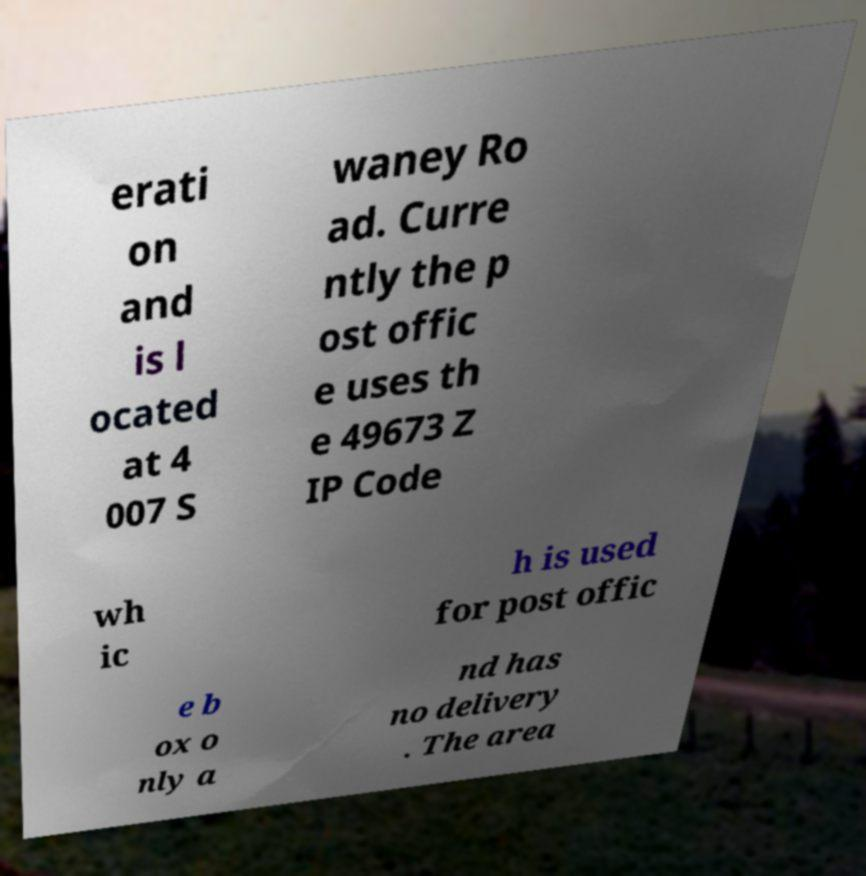What messages or text are displayed in this image? I need them in a readable, typed format. erati on and is l ocated at 4 007 S waney Ro ad. Curre ntly the p ost offic e uses th e 49673 Z IP Code wh ic h is used for post offic e b ox o nly a nd has no delivery . The area 